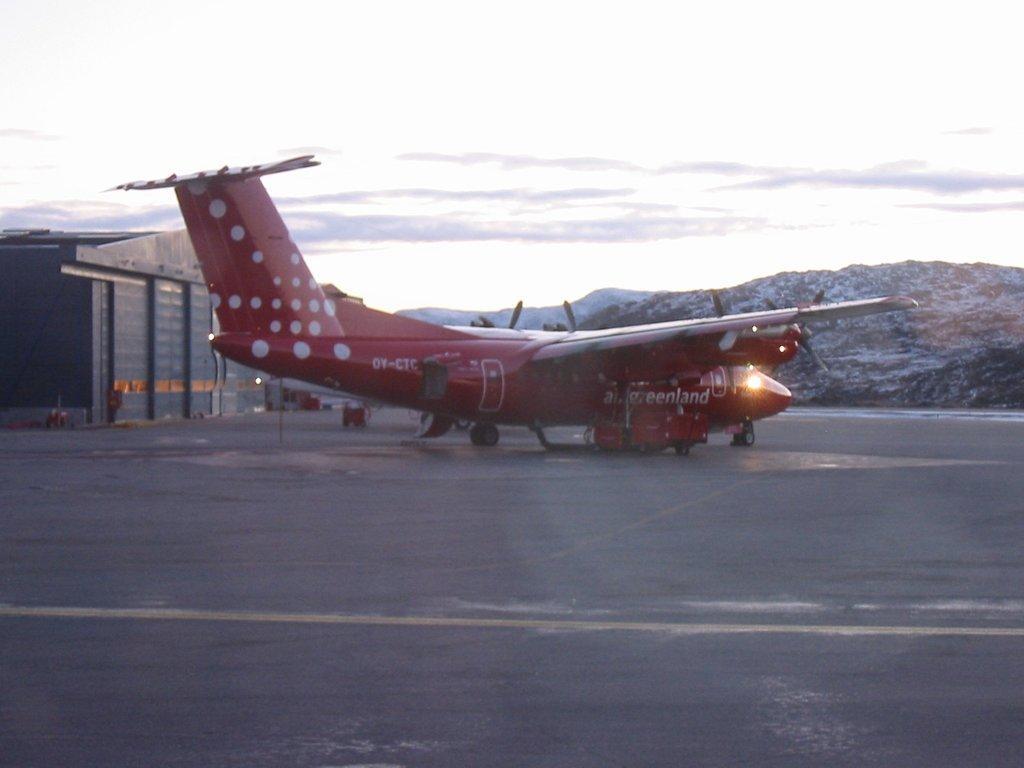Please provide a concise description of this image. We can see airplane on the road and we can see shed. In the background we can see hills and sky with clouds. 